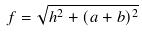Convert formula to latex. <formula><loc_0><loc_0><loc_500><loc_500>f = \sqrt { h ^ { 2 } + ( a + b ) ^ { 2 } }</formula> 